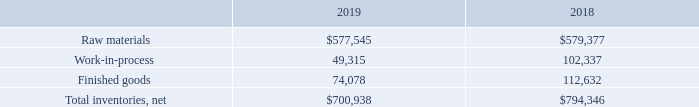2. Inventories
Inventories as of September 28, 2019 and September 29, 2018 consisted of the following (in thousands):
In certain circumstances, per contractual terms, customer deposits are received by the Company to offset obsolete and excess inventory risks. The total amount of customer deposits related to inventory and included within current liabilities on the accompanying Consolidated Balance Sheets as of September 28, 2019 and September 29, 2018 was $136.5 million and $87.7 million, respectively.
In fiscal 2019, the Company adopted and applied Topic 606 to all contracts using the modified retrospective method of adoption. The prior year comparative information has not been restated and continues to be reported under the accounting standards in effect for fiscal 2018. Refer to Note 15, "Revenue from Contracts with Customers," for further information.
Which years does the table provide information for inventories? 2019, 2018. What was the amount of Work-in-process in 2018?
Answer scale should be: thousand. 102,337. What was the amount of customer deposits related to inventory and included within current liabilities on the accompanying Consolidated Balance Sheets in 2019?
Answer scale should be: million. 136.5. How many years did net total inventories exceed $700,000 thousand? 2019##2018
Answer: 2. What was the change in the amount of Finished goods between 2018 and 2019?
Answer scale should be: thousand. 74,078-112,632
Answer: -38554. What was the percentage change in the work-in-process between 2018 and 2019?
Answer scale should be: percent. (49,315-102,337)/102,337
Answer: -51.81. 